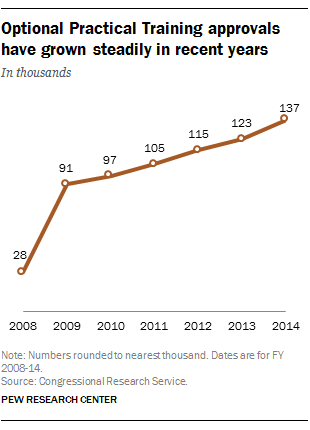Give some essential details in this illustration. The line graph is covered for a total of 7 years. What is the minimum value of the line that passes through the points (28, 10) and (32, 16)? 